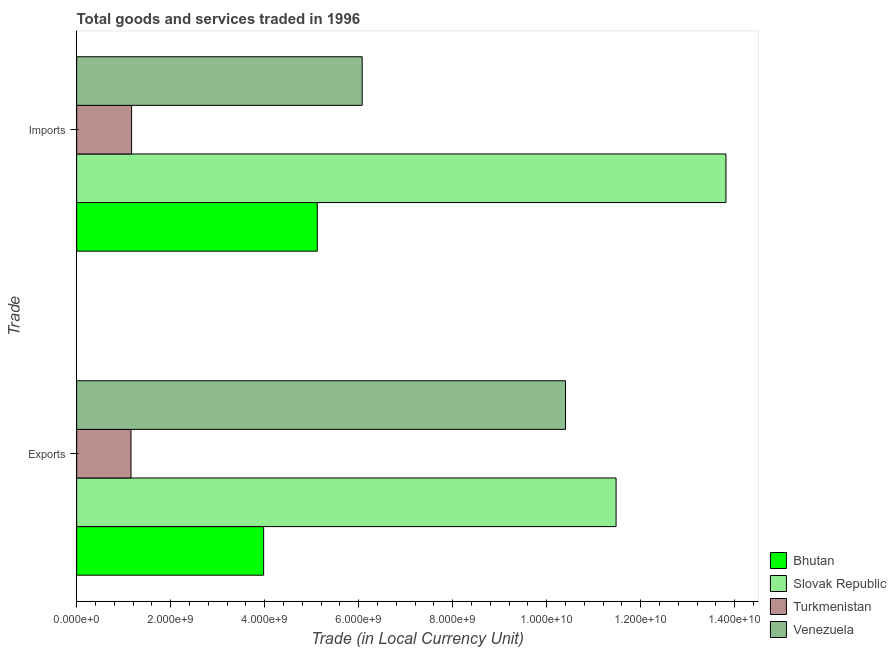How many groups of bars are there?
Your response must be concise. 2. Are the number of bars per tick equal to the number of legend labels?
Provide a succinct answer. Yes. How many bars are there on the 2nd tick from the top?
Keep it short and to the point. 4. What is the label of the 1st group of bars from the top?
Provide a short and direct response. Imports. What is the imports of goods and services in Bhutan?
Provide a succinct answer. 5.12e+09. Across all countries, what is the maximum imports of goods and services?
Give a very brief answer. 1.38e+1. Across all countries, what is the minimum export of goods and services?
Make the answer very short. 1.16e+09. In which country was the export of goods and services maximum?
Offer a terse response. Slovak Republic. In which country was the imports of goods and services minimum?
Your answer should be very brief. Turkmenistan. What is the total imports of goods and services in the graph?
Provide a succinct answer. 2.62e+1. What is the difference between the imports of goods and services in Slovak Republic and that in Bhutan?
Provide a short and direct response. 8.70e+09. What is the difference between the export of goods and services in Venezuela and the imports of goods and services in Bhutan?
Give a very brief answer. 5.28e+09. What is the average imports of goods and services per country?
Offer a terse response. 6.54e+09. What is the difference between the export of goods and services and imports of goods and services in Turkmenistan?
Offer a very short reply. -1.28e+07. In how many countries, is the imports of goods and services greater than 10800000000 LCU?
Your response must be concise. 1. What is the ratio of the imports of goods and services in Slovak Republic to that in Venezuela?
Your answer should be very brief. 2.27. Is the export of goods and services in Turkmenistan less than that in Bhutan?
Give a very brief answer. Yes. In how many countries, is the imports of goods and services greater than the average imports of goods and services taken over all countries?
Offer a very short reply. 1. What does the 2nd bar from the top in Imports represents?
Your answer should be very brief. Turkmenistan. What does the 2nd bar from the bottom in Imports represents?
Provide a short and direct response. Slovak Republic. Are the values on the major ticks of X-axis written in scientific E-notation?
Your response must be concise. Yes. Where does the legend appear in the graph?
Your answer should be very brief. Bottom right. How are the legend labels stacked?
Offer a terse response. Vertical. What is the title of the graph?
Your answer should be very brief. Total goods and services traded in 1996. Does "French Polynesia" appear as one of the legend labels in the graph?
Ensure brevity in your answer.  No. What is the label or title of the X-axis?
Provide a succinct answer. Trade (in Local Currency Unit). What is the label or title of the Y-axis?
Offer a very short reply. Trade. What is the Trade (in Local Currency Unit) of Bhutan in Exports?
Ensure brevity in your answer.  3.98e+09. What is the Trade (in Local Currency Unit) in Slovak Republic in Exports?
Give a very brief answer. 1.15e+1. What is the Trade (in Local Currency Unit) of Turkmenistan in Exports?
Give a very brief answer. 1.16e+09. What is the Trade (in Local Currency Unit) in Venezuela in Exports?
Provide a short and direct response. 1.04e+1. What is the Trade (in Local Currency Unit) of Bhutan in Imports?
Offer a very short reply. 5.12e+09. What is the Trade (in Local Currency Unit) in Slovak Republic in Imports?
Keep it short and to the point. 1.38e+1. What is the Trade (in Local Currency Unit) in Turkmenistan in Imports?
Your answer should be compact. 1.17e+09. What is the Trade (in Local Currency Unit) in Venezuela in Imports?
Offer a terse response. 6.08e+09. Across all Trade, what is the maximum Trade (in Local Currency Unit) in Bhutan?
Your answer should be very brief. 5.12e+09. Across all Trade, what is the maximum Trade (in Local Currency Unit) in Slovak Republic?
Keep it short and to the point. 1.38e+1. Across all Trade, what is the maximum Trade (in Local Currency Unit) in Turkmenistan?
Offer a terse response. 1.17e+09. Across all Trade, what is the maximum Trade (in Local Currency Unit) in Venezuela?
Provide a succinct answer. 1.04e+1. Across all Trade, what is the minimum Trade (in Local Currency Unit) of Bhutan?
Your response must be concise. 3.98e+09. Across all Trade, what is the minimum Trade (in Local Currency Unit) of Slovak Republic?
Give a very brief answer. 1.15e+1. Across all Trade, what is the minimum Trade (in Local Currency Unit) of Turkmenistan?
Offer a terse response. 1.16e+09. Across all Trade, what is the minimum Trade (in Local Currency Unit) in Venezuela?
Provide a short and direct response. 6.08e+09. What is the total Trade (in Local Currency Unit) in Bhutan in the graph?
Make the answer very short. 9.10e+09. What is the total Trade (in Local Currency Unit) of Slovak Republic in the graph?
Offer a very short reply. 2.53e+1. What is the total Trade (in Local Currency Unit) in Turkmenistan in the graph?
Keep it short and to the point. 2.33e+09. What is the total Trade (in Local Currency Unit) in Venezuela in the graph?
Make the answer very short. 1.65e+1. What is the difference between the Trade (in Local Currency Unit) of Bhutan in Exports and that in Imports?
Your response must be concise. -1.14e+09. What is the difference between the Trade (in Local Currency Unit) of Slovak Republic in Exports and that in Imports?
Provide a short and direct response. -2.34e+09. What is the difference between the Trade (in Local Currency Unit) of Turkmenistan in Exports and that in Imports?
Offer a very short reply. -1.28e+07. What is the difference between the Trade (in Local Currency Unit) in Venezuela in Exports and that in Imports?
Your answer should be compact. 4.33e+09. What is the difference between the Trade (in Local Currency Unit) of Bhutan in Exports and the Trade (in Local Currency Unit) of Slovak Republic in Imports?
Your response must be concise. -9.84e+09. What is the difference between the Trade (in Local Currency Unit) of Bhutan in Exports and the Trade (in Local Currency Unit) of Turkmenistan in Imports?
Ensure brevity in your answer.  2.81e+09. What is the difference between the Trade (in Local Currency Unit) of Bhutan in Exports and the Trade (in Local Currency Unit) of Venezuela in Imports?
Offer a terse response. -2.10e+09. What is the difference between the Trade (in Local Currency Unit) in Slovak Republic in Exports and the Trade (in Local Currency Unit) in Turkmenistan in Imports?
Provide a short and direct response. 1.03e+1. What is the difference between the Trade (in Local Currency Unit) of Slovak Republic in Exports and the Trade (in Local Currency Unit) of Venezuela in Imports?
Provide a short and direct response. 5.40e+09. What is the difference between the Trade (in Local Currency Unit) in Turkmenistan in Exports and the Trade (in Local Currency Unit) in Venezuela in Imports?
Make the answer very short. -4.92e+09. What is the average Trade (in Local Currency Unit) of Bhutan per Trade?
Offer a very short reply. 4.55e+09. What is the average Trade (in Local Currency Unit) of Slovak Republic per Trade?
Ensure brevity in your answer.  1.26e+1. What is the average Trade (in Local Currency Unit) in Turkmenistan per Trade?
Give a very brief answer. 1.16e+09. What is the average Trade (in Local Currency Unit) of Venezuela per Trade?
Your response must be concise. 8.24e+09. What is the difference between the Trade (in Local Currency Unit) of Bhutan and Trade (in Local Currency Unit) of Slovak Republic in Exports?
Offer a terse response. -7.50e+09. What is the difference between the Trade (in Local Currency Unit) of Bhutan and Trade (in Local Currency Unit) of Turkmenistan in Exports?
Your answer should be compact. 2.82e+09. What is the difference between the Trade (in Local Currency Unit) of Bhutan and Trade (in Local Currency Unit) of Venezuela in Exports?
Your answer should be compact. -6.42e+09. What is the difference between the Trade (in Local Currency Unit) in Slovak Republic and Trade (in Local Currency Unit) in Turkmenistan in Exports?
Provide a short and direct response. 1.03e+1. What is the difference between the Trade (in Local Currency Unit) in Slovak Republic and Trade (in Local Currency Unit) in Venezuela in Exports?
Offer a very short reply. 1.08e+09. What is the difference between the Trade (in Local Currency Unit) in Turkmenistan and Trade (in Local Currency Unit) in Venezuela in Exports?
Ensure brevity in your answer.  -9.25e+09. What is the difference between the Trade (in Local Currency Unit) of Bhutan and Trade (in Local Currency Unit) of Slovak Republic in Imports?
Provide a succinct answer. -8.70e+09. What is the difference between the Trade (in Local Currency Unit) in Bhutan and Trade (in Local Currency Unit) in Turkmenistan in Imports?
Offer a very short reply. 3.95e+09. What is the difference between the Trade (in Local Currency Unit) of Bhutan and Trade (in Local Currency Unit) of Venezuela in Imports?
Your response must be concise. -9.56e+08. What is the difference between the Trade (in Local Currency Unit) of Slovak Republic and Trade (in Local Currency Unit) of Turkmenistan in Imports?
Ensure brevity in your answer.  1.26e+1. What is the difference between the Trade (in Local Currency Unit) of Slovak Republic and Trade (in Local Currency Unit) of Venezuela in Imports?
Give a very brief answer. 7.74e+09. What is the difference between the Trade (in Local Currency Unit) in Turkmenistan and Trade (in Local Currency Unit) in Venezuela in Imports?
Keep it short and to the point. -4.91e+09. What is the ratio of the Trade (in Local Currency Unit) in Bhutan in Exports to that in Imports?
Your response must be concise. 0.78. What is the ratio of the Trade (in Local Currency Unit) of Slovak Republic in Exports to that in Imports?
Your answer should be compact. 0.83. What is the ratio of the Trade (in Local Currency Unit) of Venezuela in Exports to that in Imports?
Make the answer very short. 1.71. What is the difference between the highest and the second highest Trade (in Local Currency Unit) of Bhutan?
Ensure brevity in your answer.  1.14e+09. What is the difference between the highest and the second highest Trade (in Local Currency Unit) in Slovak Republic?
Your response must be concise. 2.34e+09. What is the difference between the highest and the second highest Trade (in Local Currency Unit) in Turkmenistan?
Keep it short and to the point. 1.28e+07. What is the difference between the highest and the second highest Trade (in Local Currency Unit) of Venezuela?
Your response must be concise. 4.33e+09. What is the difference between the highest and the lowest Trade (in Local Currency Unit) of Bhutan?
Offer a terse response. 1.14e+09. What is the difference between the highest and the lowest Trade (in Local Currency Unit) in Slovak Republic?
Your answer should be very brief. 2.34e+09. What is the difference between the highest and the lowest Trade (in Local Currency Unit) in Turkmenistan?
Provide a succinct answer. 1.28e+07. What is the difference between the highest and the lowest Trade (in Local Currency Unit) of Venezuela?
Give a very brief answer. 4.33e+09. 